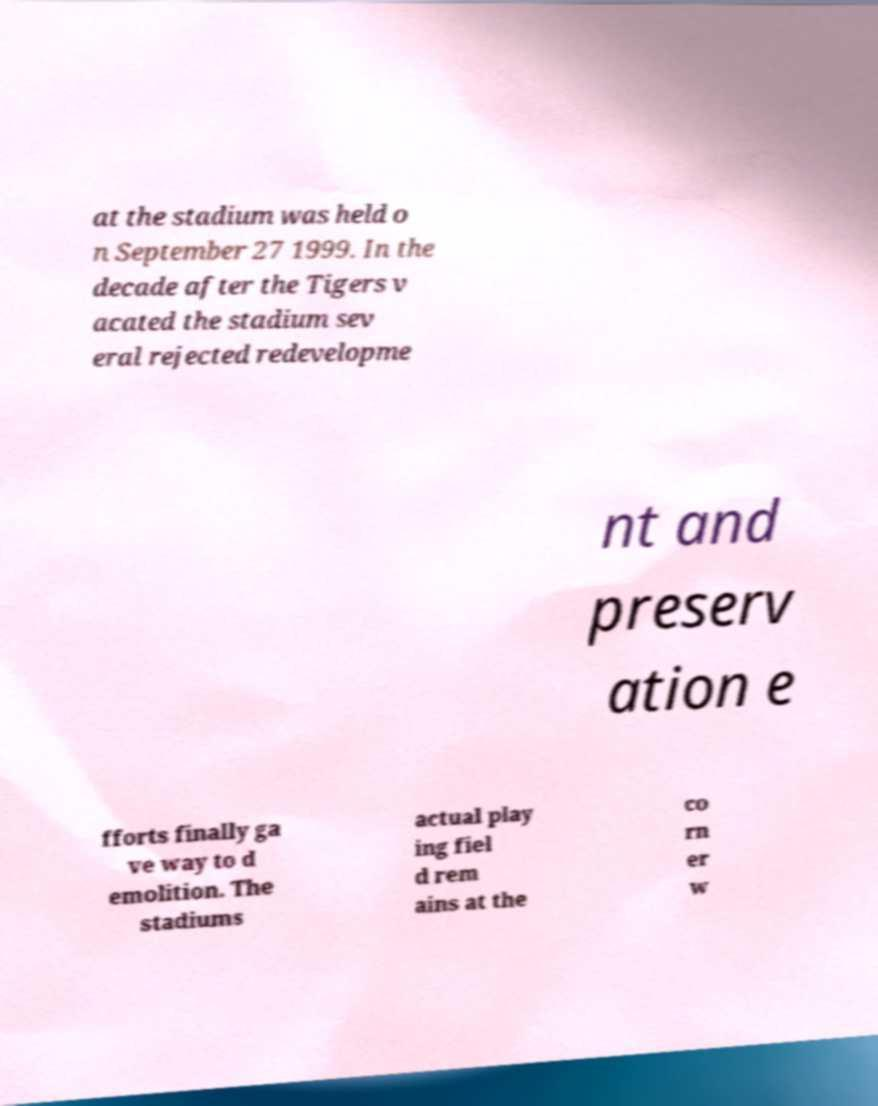Can you read and provide the text displayed in the image?This photo seems to have some interesting text. Can you extract and type it out for me? at the stadium was held o n September 27 1999. In the decade after the Tigers v acated the stadium sev eral rejected redevelopme nt and preserv ation e fforts finally ga ve way to d emolition. The stadiums actual play ing fiel d rem ains at the co rn er w 